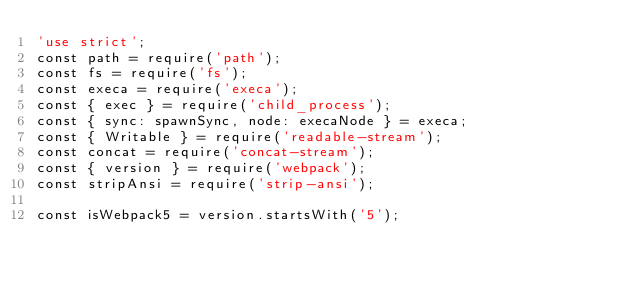Convert code to text. <code><loc_0><loc_0><loc_500><loc_500><_JavaScript_>'use strict';
const path = require('path');
const fs = require('fs');
const execa = require('execa');
const { exec } = require('child_process');
const { sync: spawnSync, node: execaNode } = execa;
const { Writable } = require('readable-stream');
const concat = require('concat-stream');
const { version } = require('webpack');
const stripAnsi = require('strip-ansi');

const isWebpack5 = version.startsWith('5');
</code> 